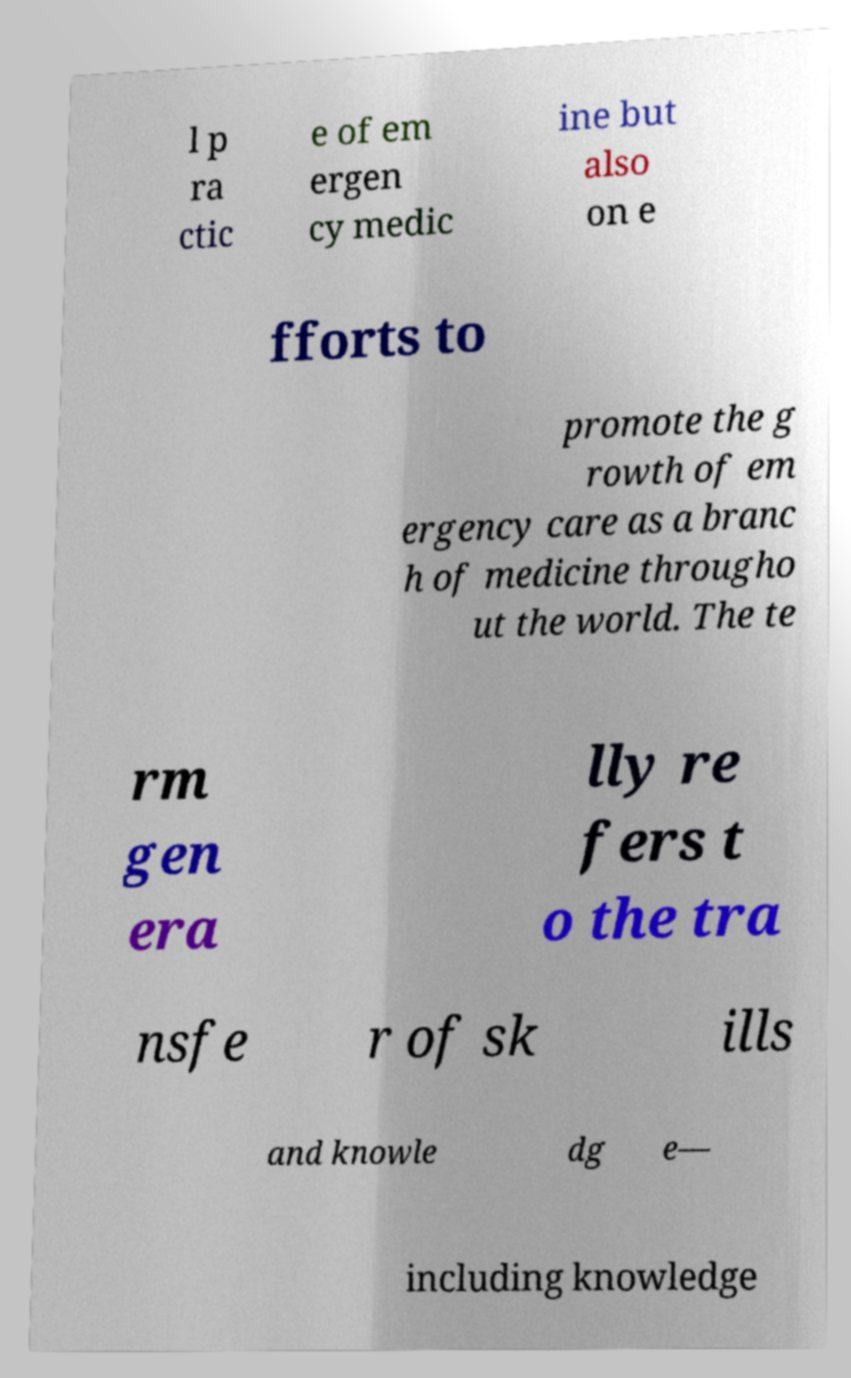Could you assist in decoding the text presented in this image and type it out clearly? l p ra ctic e of em ergen cy medic ine but also on e fforts to promote the g rowth of em ergency care as a branc h of medicine througho ut the world. The te rm gen era lly re fers t o the tra nsfe r of sk ills and knowle dg e— including knowledge 